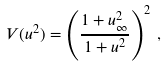Convert formula to latex. <formula><loc_0><loc_0><loc_500><loc_500>V ( u ^ { 2 } ) = \left ( \frac { 1 + u _ { \infty } ^ { 2 } } { 1 + u ^ { 2 } } \right ) ^ { 2 } \, ,</formula> 